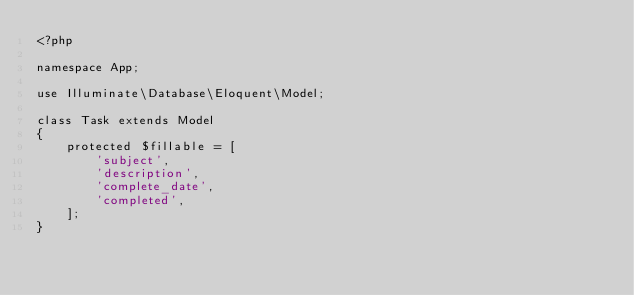<code> <loc_0><loc_0><loc_500><loc_500><_PHP_><?php

namespace App;

use Illuminate\Database\Eloquent\Model;

class Task extends Model
{
    protected $fillable = [
        'subject',
        'description',
        'complete_date',
        'completed',
    ];
}
</code> 